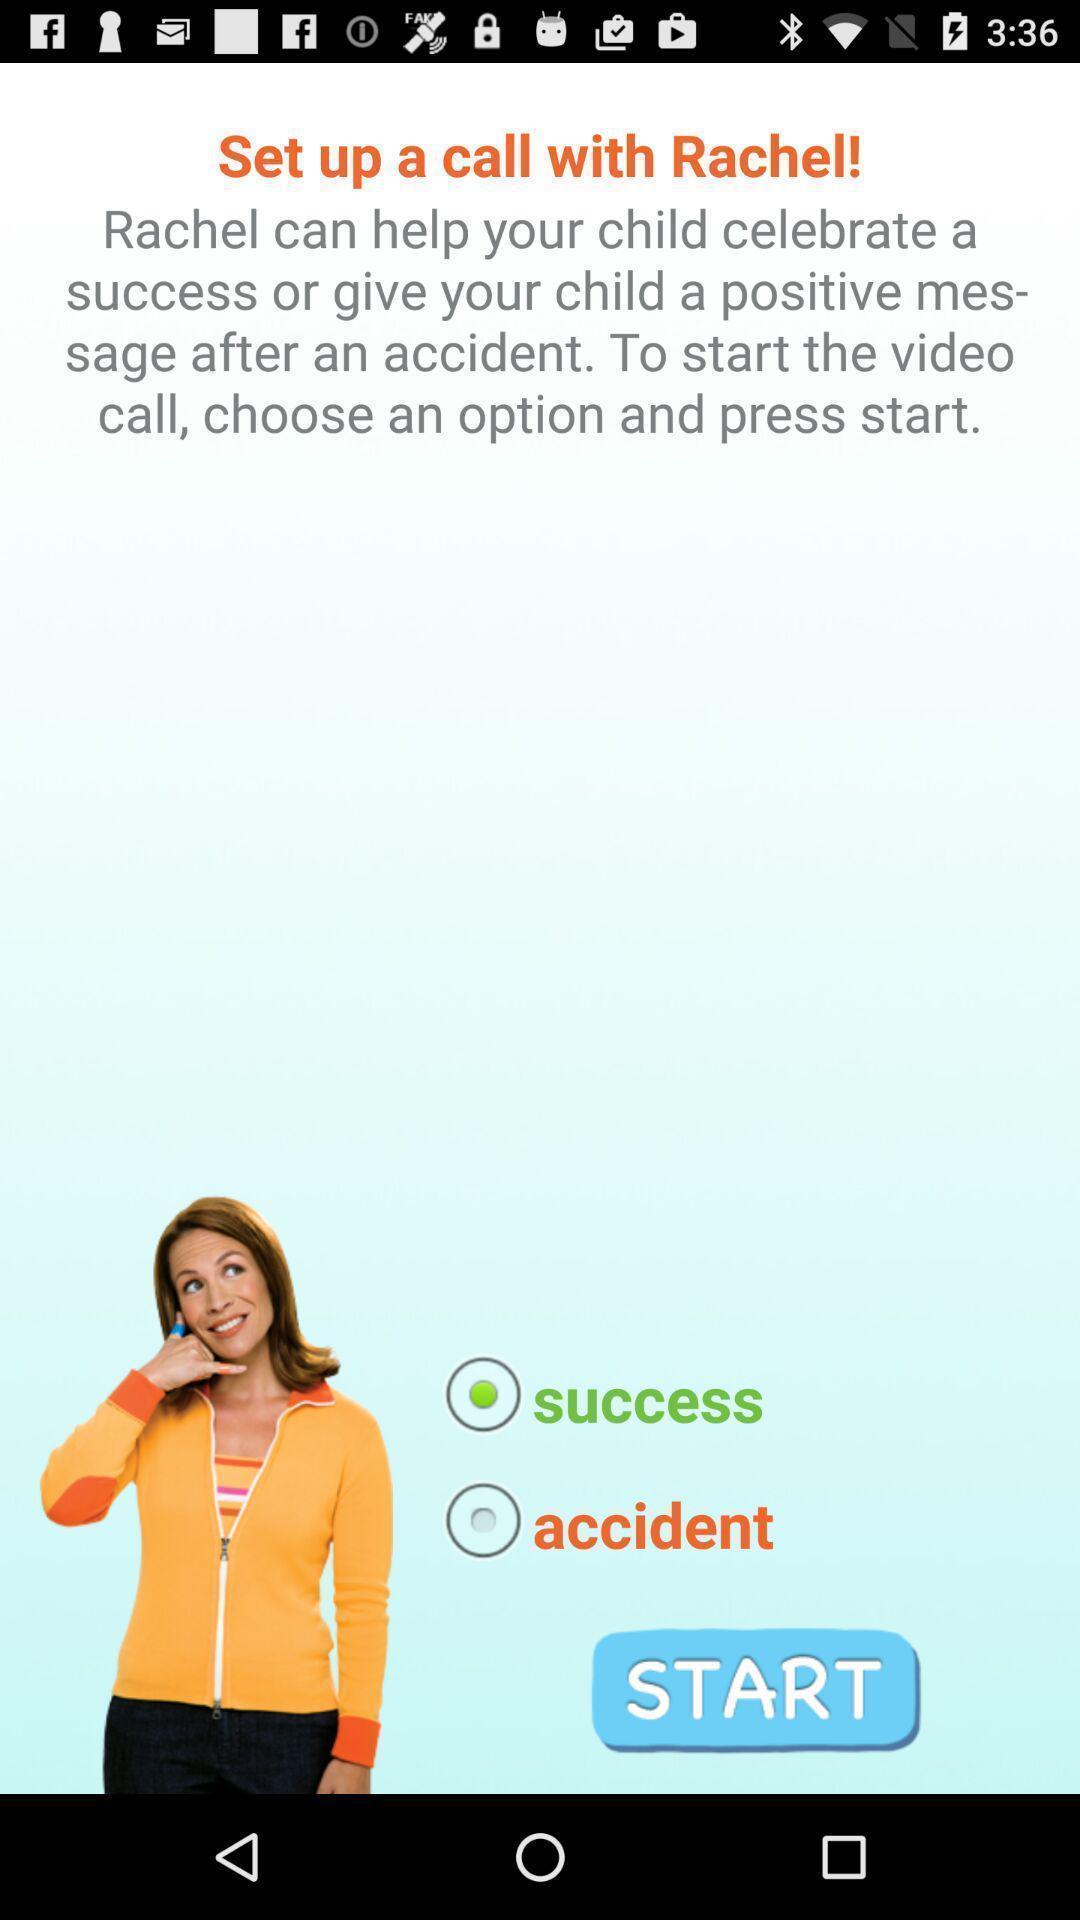Please provide a description for this image. Welcome screen. 